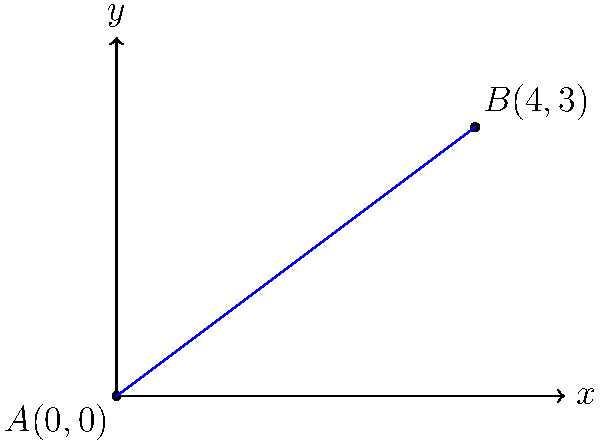You're designing a skirt with an asymmetrical hem. The hem passes through two points on your design: $A(0,0)$ and $B(4,3)$. Find the equation of the line representing this hem in slope-intercept form $(y = mx + b)$. To find the equation of the line, we'll follow these steps:

1) Calculate the slope $(m)$ using the slope formula:
   $m = \frac{y_2 - y_1}{x_2 - x_1} = \frac{3 - 0}{4 - 0} = \frac{3}{4}$

2) Use the point-slope form of a line with point $A(0,0)$:
   $y - y_1 = m(x - x_1)$
   $y - 0 = \frac{3}{4}(x - 0)$

3) Simplify:
   $y = \frac{3}{4}x$

4) The y-intercept $(b)$ is 0, so our equation is already in slope-intercept form.

Therefore, the equation of the line representing the hem of the skirt is $y = \frac{3}{4}x$.
Answer: $y = \frac{3}{4}x$ 